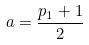<formula> <loc_0><loc_0><loc_500><loc_500>a = \frac { p _ { 1 } + 1 } { 2 }</formula> 